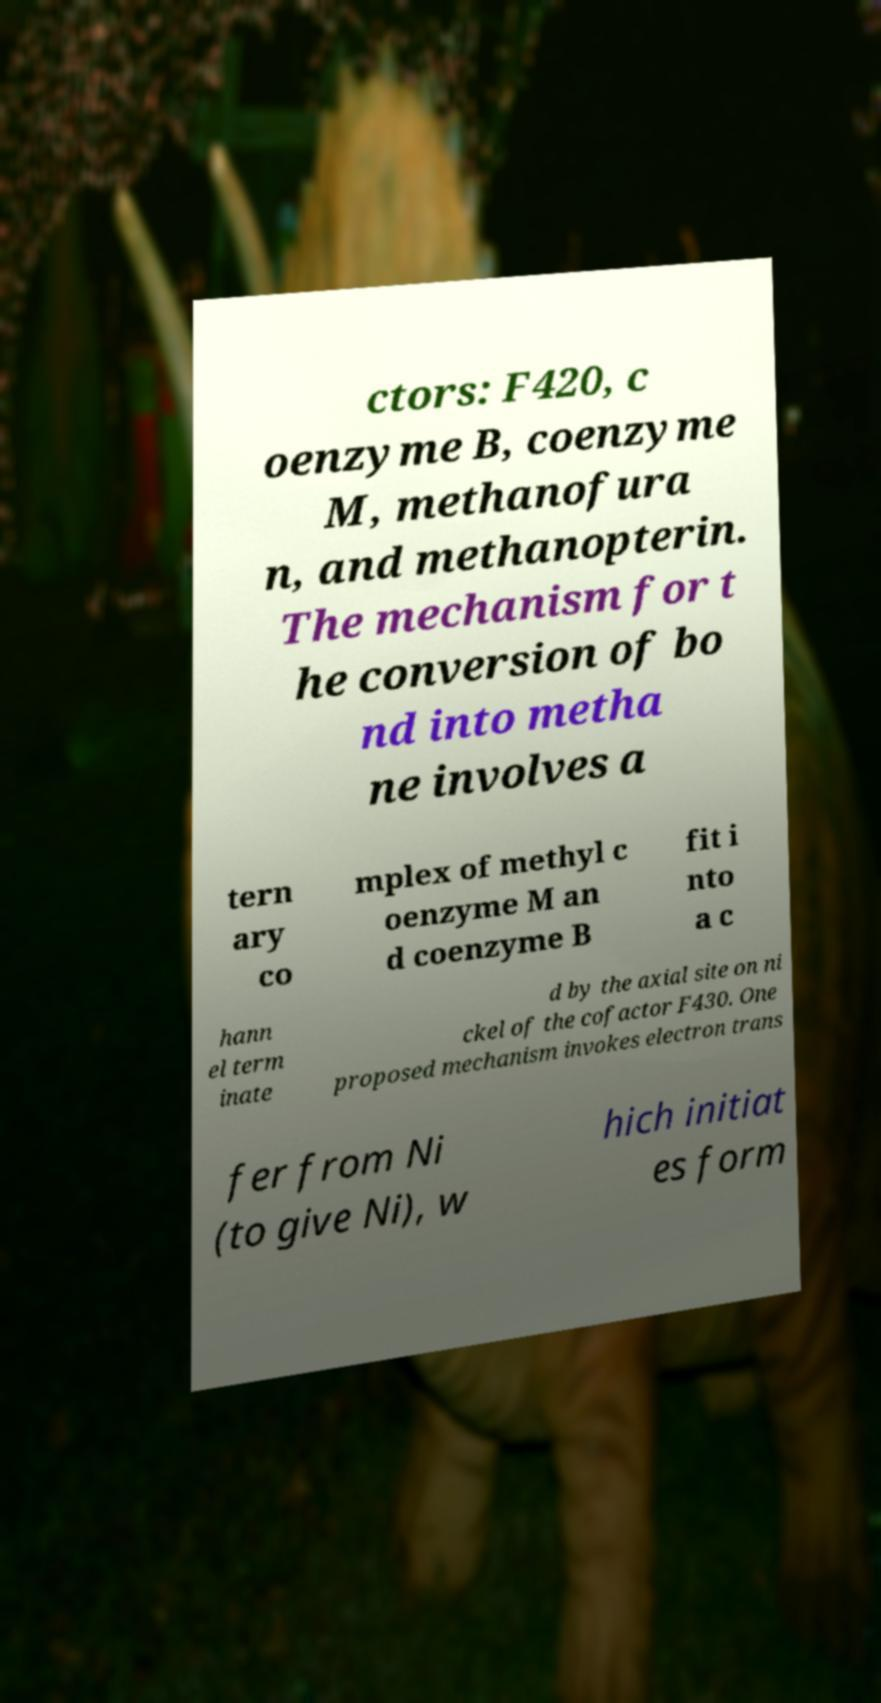Please read and relay the text visible in this image. What does it say? ctors: F420, c oenzyme B, coenzyme M, methanofura n, and methanopterin. The mechanism for t he conversion of bo nd into metha ne involves a tern ary co mplex of methyl c oenzyme M an d coenzyme B fit i nto a c hann el term inate d by the axial site on ni ckel of the cofactor F430. One proposed mechanism invokes electron trans fer from Ni (to give Ni), w hich initiat es form 